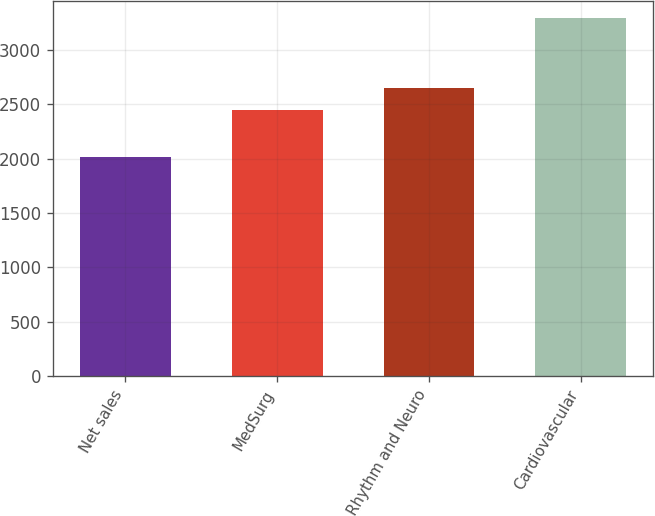Convert chart. <chart><loc_0><loc_0><loc_500><loc_500><bar_chart><fcel>Net sales<fcel>MedSurg<fcel>Rhythm and Neuro<fcel>Cardiovascular<nl><fcel>2016<fcel>2445<fcel>2649<fcel>3292<nl></chart> 